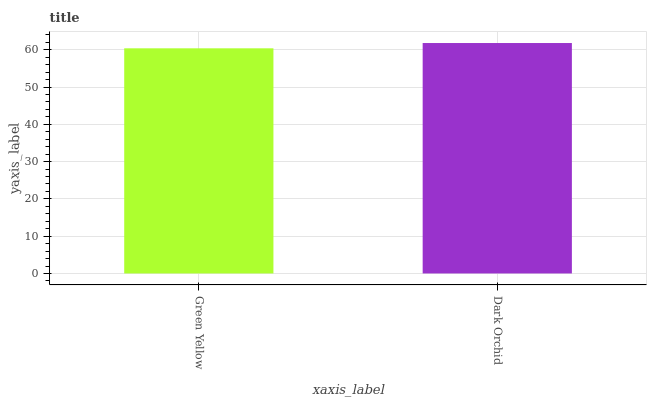Is Green Yellow the minimum?
Answer yes or no. Yes. Is Dark Orchid the maximum?
Answer yes or no. Yes. Is Dark Orchid the minimum?
Answer yes or no. No. Is Dark Orchid greater than Green Yellow?
Answer yes or no. Yes. Is Green Yellow less than Dark Orchid?
Answer yes or no. Yes. Is Green Yellow greater than Dark Orchid?
Answer yes or no. No. Is Dark Orchid less than Green Yellow?
Answer yes or no. No. Is Dark Orchid the high median?
Answer yes or no. Yes. Is Green Yellow the low median?
Answer yes or no. Yes. Is Green Yellow the high median?
Answer yes or no. No. Is Dark Orchid the low median?
Answer yes or no. No. 